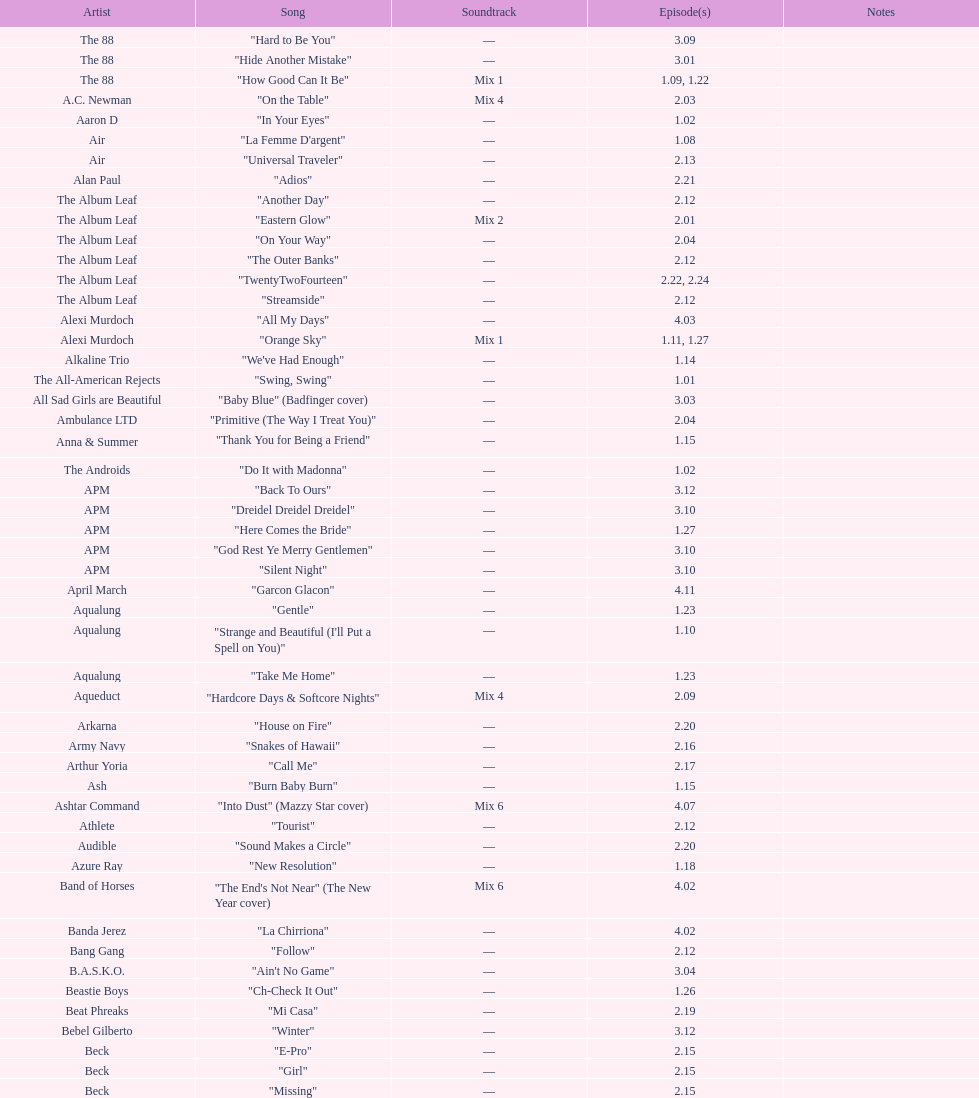How many episodes are below 2.00? 27. 